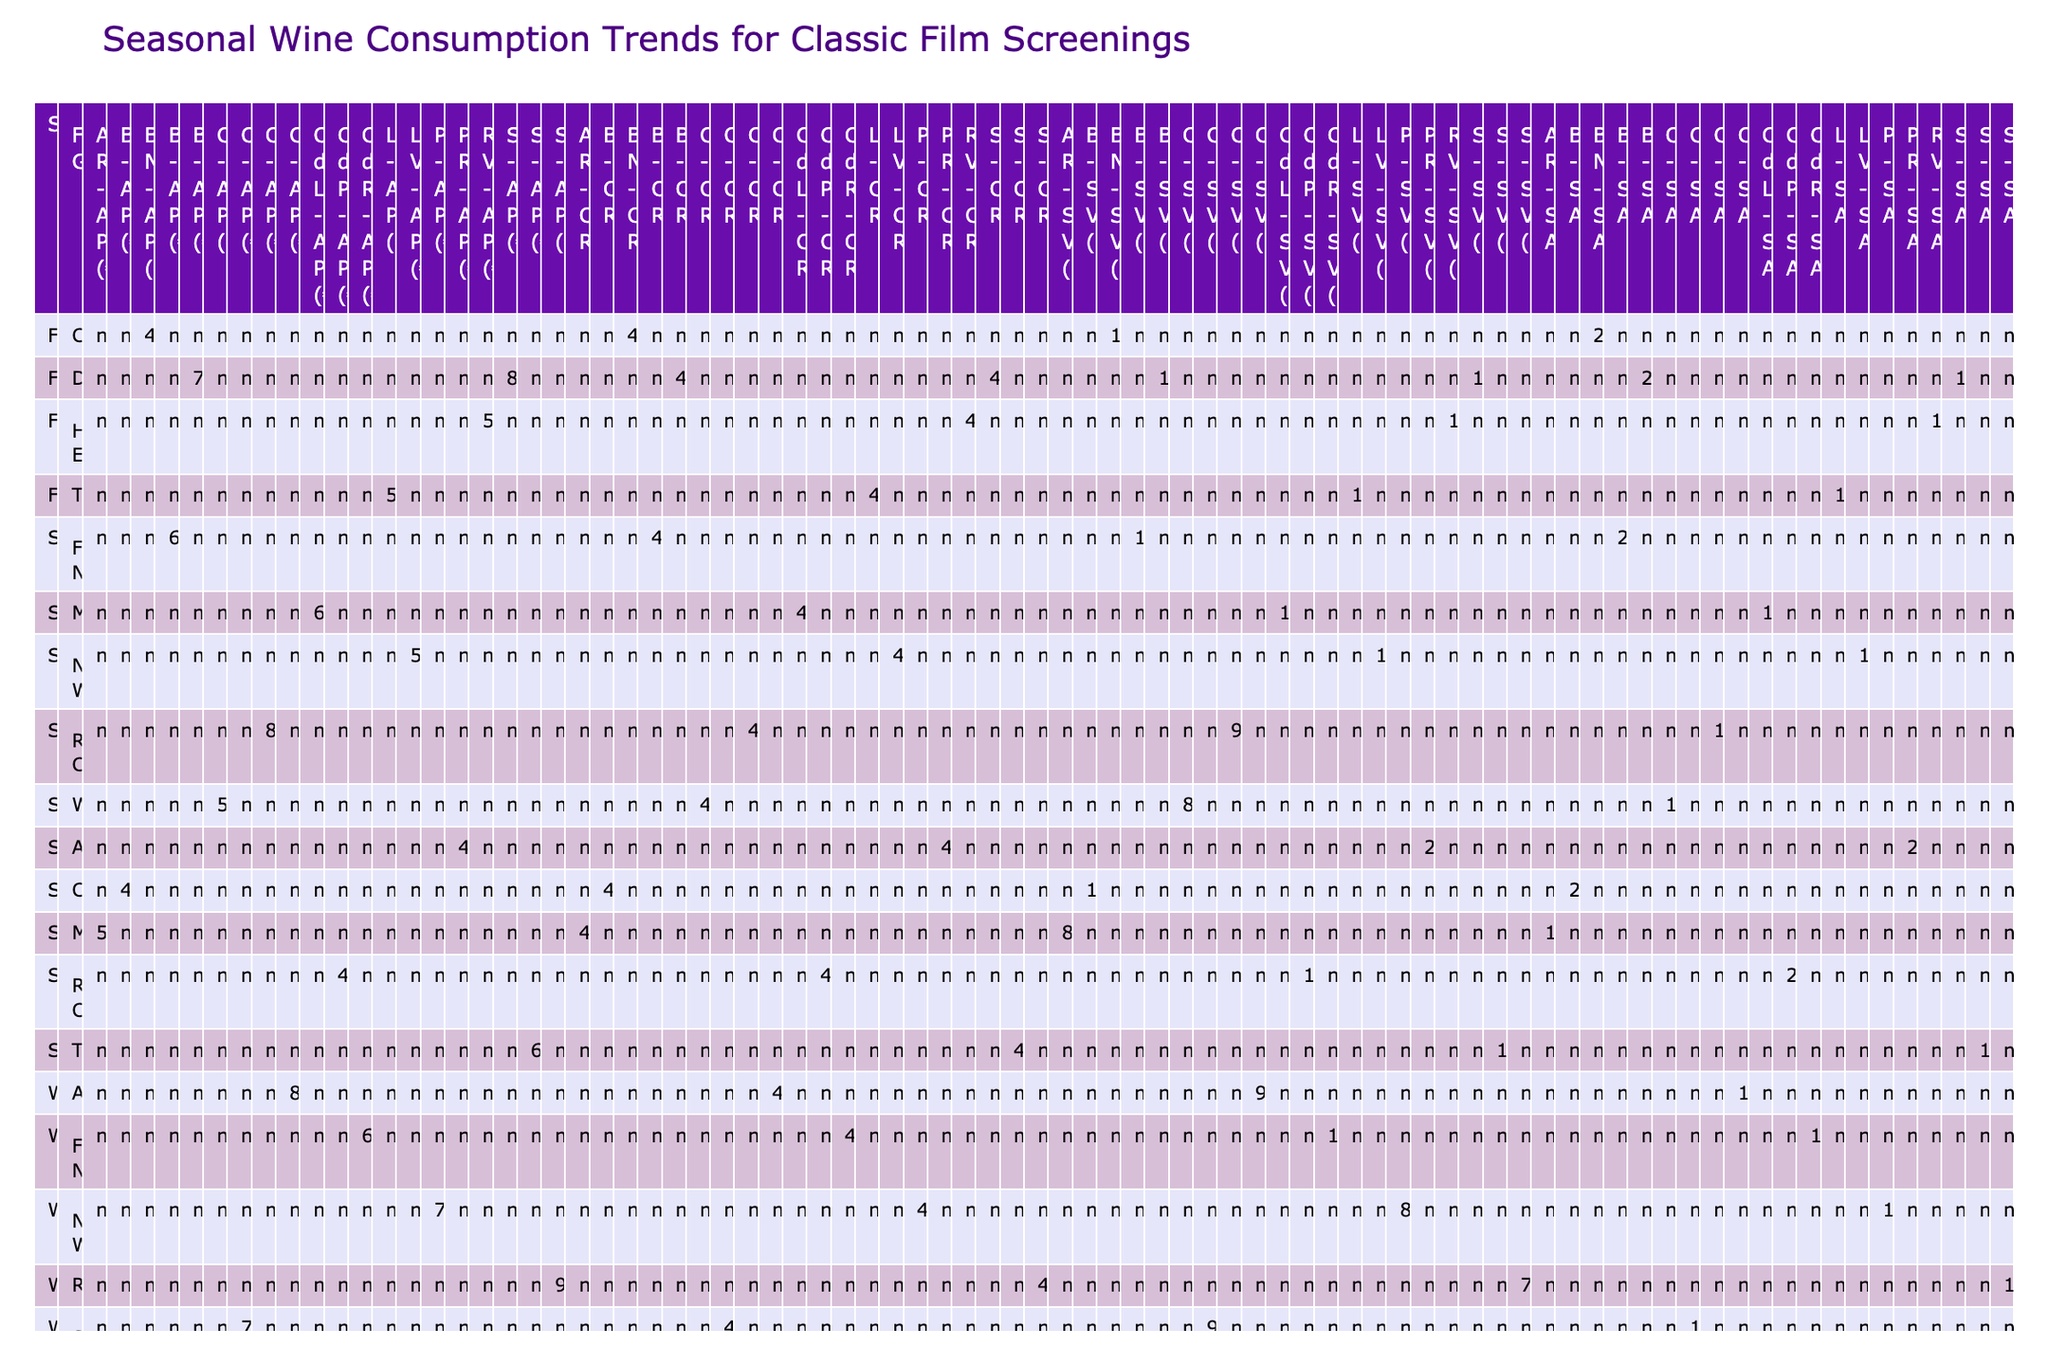What is the total sales volume of Bordeaux wines during the Spring season? In the Spring season, the only entry for Bordeaux is under the Film Noir genre with a sales volume of 145 bottles. Since it's the only value for that wine varietal in Spring, the total sales volume for Bordeaux during this season is simply 145.
Answer: 145 Which wine varietal had the highest average price in Winter? In the Winter season, the average prices for each wine varietal are as follows: Sauternes (95), Côtes du Rhône (60), and Chablis (70). The highest among these is Sauternes with an average price of 95.
Answer: 95 Did the average customer rating for Romantic Comedy films exceed 4.5 across all seasons? The average customer ratings for Romantic Comedy across the seasons are: Spring (4.5 with Champagne), Summer (4.4 with Côtes de Provence), and there are no entries in Fall and Winter. The highest rating of 4.5 in Spring indicates that the average customer rating does not exceed 4.5 across all seasons.
Answer: No What is the difference in screening attendance between Adventure films in Summer and Winter? In Summer, Adventure films had a screening attendance of 245, while in Winter, they had 96. The difference is calculated as 245 - 96, which equals 149.
Answer: 149 Which wine varietal had the lowest customer rating during Fall drama screenings? In Fall, there are two entries for Drama: Burgundy (4.6) and Saint-Émilion (4.5). The lowest customer rating is for Saint-Émilion with a rating of 4.5.
Answer: Saint-Émilion How many more bottles of Provence Rosé were sold compared to Alsace Riesling in the Summer? In the Summer, Provence Rosé sold 201 bottles, while Alsace Riesling sold 87 bottles. The difference in sales is 201 - 87, which gives us 114 more bottles sold for Provence Rosé.
Answer: 114 Is it true that the sales volume for Beaujolais Nouveau in Fall was greater than for Languedoc in the same season? In Fall, Beaujolais Nouveau had a sales volume of 167, while Languedoc had a sales volume of 105. Since 167 is greater than 105, it is true.
Answer: Yes What is the average customer rating for all wine varietals associated with Comedy films? The average customer ratings for Comedy films are Beaujolais in Summer (4.2) and Beaujolais Nouveau in Fall (4.1). To calculate the average: (4.2 + 4.1) / 2, which is 4.15.
Answer: 4.15 What is the total sales volume of wines in the Romantic Comedy genre across all seasons? In Spring, the sales volume for Champagne is 98; in Summer, for Côtes de Provence, it is 189. The total sales volume is 98 + 189 = 287.
Answer: 287 